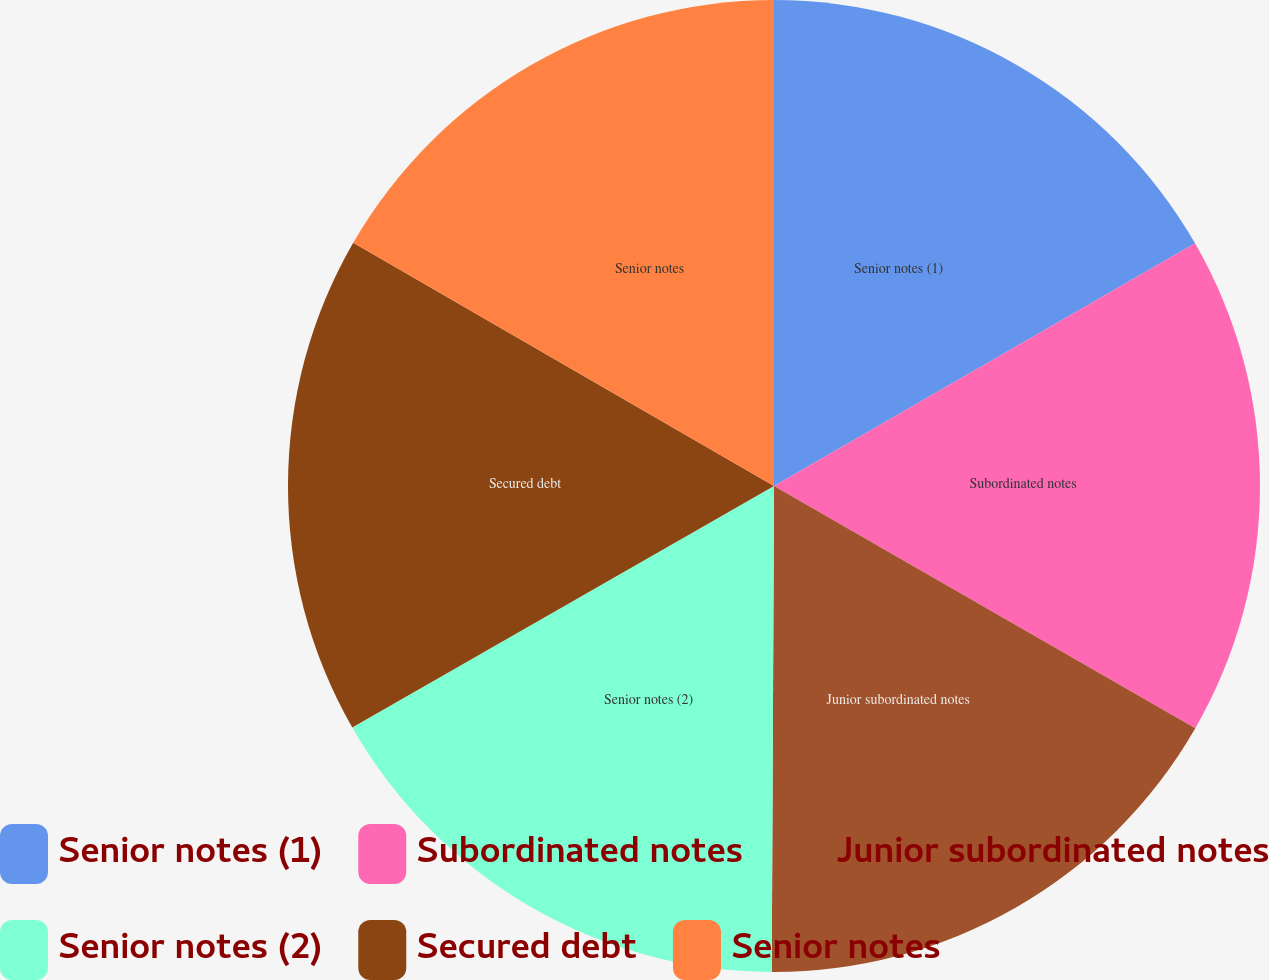Convert chart. <chart><loc_0><loc_0><loc_500><loc_500><pie_chart><fcel>Senior notes (1)<fcel>Subordinated notes<fcel>Junior subordinated notes<fcel>Senior notes (2)<fcel>Secured debt<fcel>Senior notes<nl><fcel>16.68%<fcel>16.63%<fcel>16.77%<fcel>16.65%<fcel>16.62%<fcel>16.66%<nl></chart> 